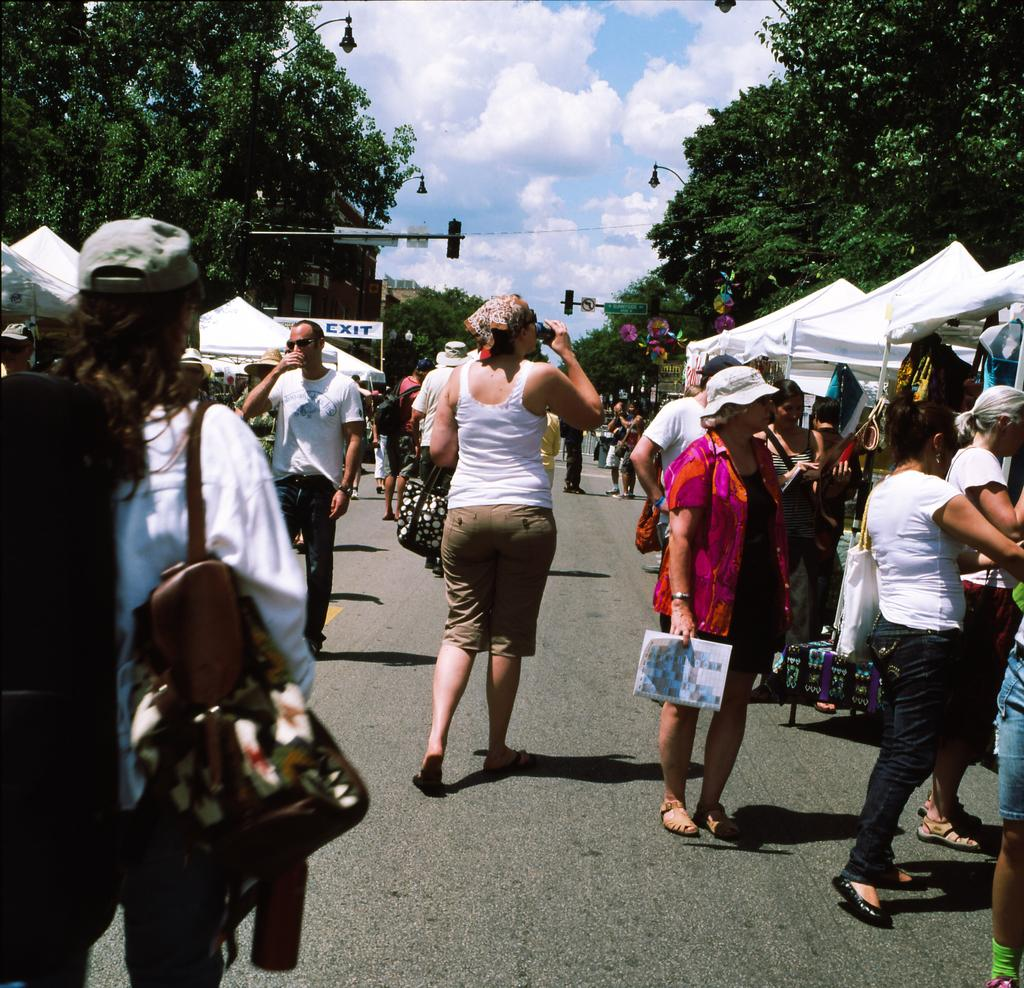How many people are in the image? There are many people in the image. Where are the people located in the image? The people are standing on the road. What can be seen on either side of the road? There are trees on either side of the road. What color is the sky in the image? The sky is blue in the image. What type of thread is being used by the bird in the image? There is no bird or thread present in the image. 